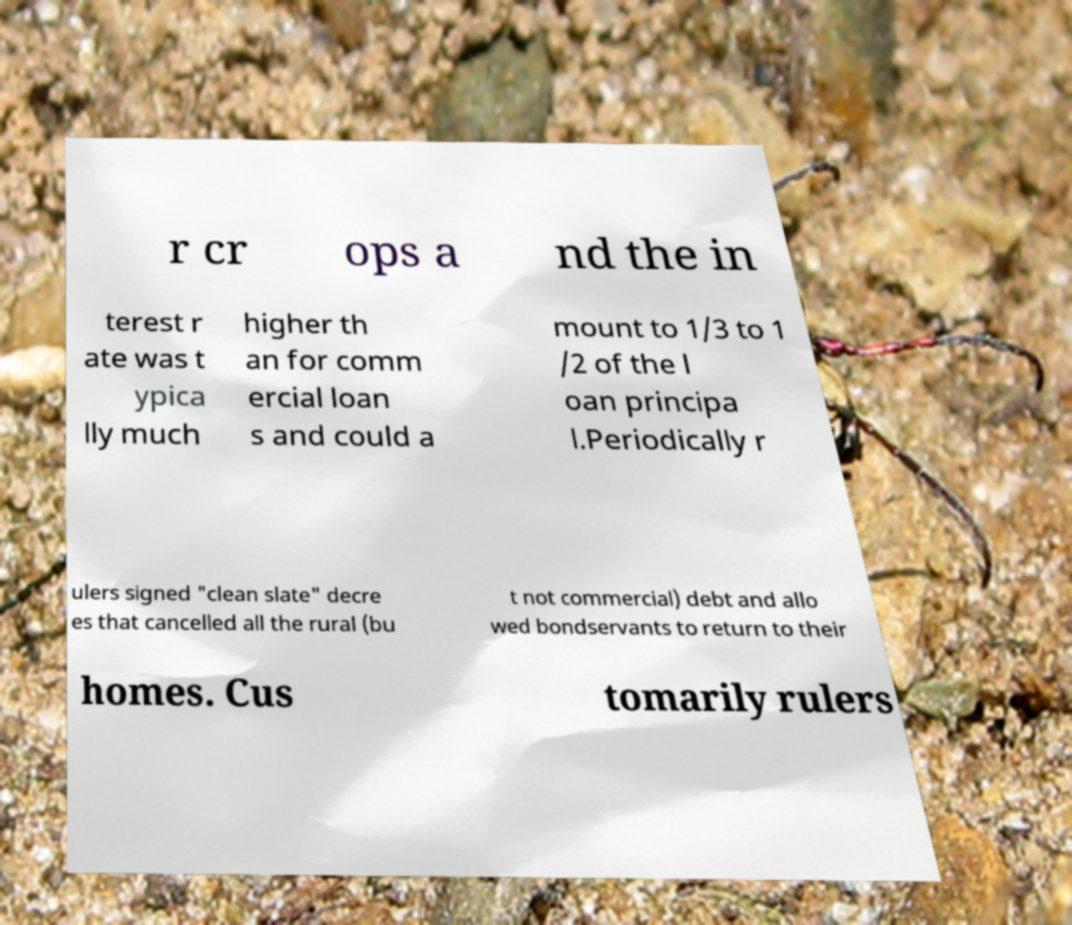I need the written content from this picture converted into text. Can you do that? r cr ops a nd the in terest r ate was t ypica lly much higher th an for comm ercial loan s and could a mount to 1/3 to 1 /2 of the l oan principa l.Periodically r ulers signed "clean slate" decre es that cancelled all the rural (bu t not commercial) debt and allo wed bondservants to return to their homes. Cus tomarily rulers 